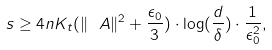Convert formula to latex. <formula><loc_0><loc_0><loc_500><loc_500>s \geq 4 n K _ { t } ( \| \ A \| ^ { 2 } + \frac { \epsilon _ { 0 } } { 3 } ) \cdot \log ( \frac { d } { \delta } ) \cdot \frac { 1 } { \epsilon _ { 0 } ^ { 2 } } ,</formula> 